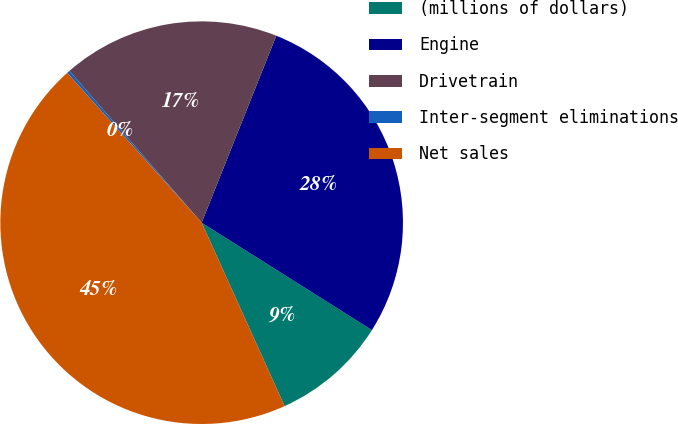Convert chart. <chart><loc_0><loc_0><loc_500><loc_500><pie_chart><fcel>(millions of dollars)<fcel>Engine<fcel>Drivetrain<fcel>Inter-segment eliminations<fcel>Net sales<nl><fcel>9.29%<fcel>27.91%<fcel>17.45%<fcel>0.24%<fcel>45.12%<nl></chart> 